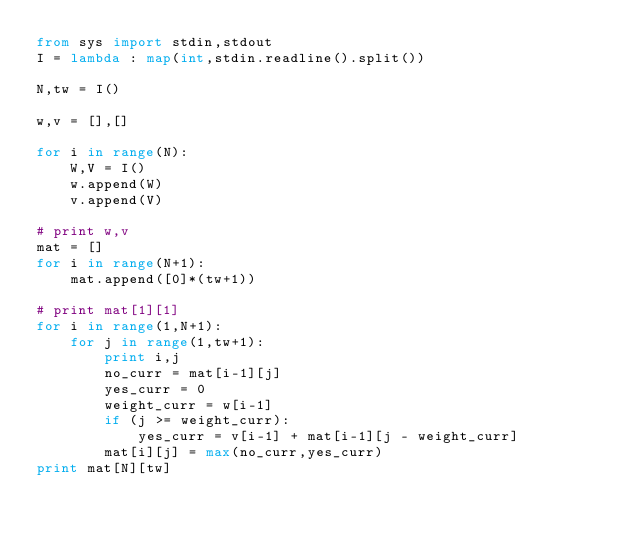Convert code to text. <code><loc_0><loc_0><loc_500><loc_500><_Python_>from sys import stdin,stdout
I = lambda : map(int,stdin.readline().split())

N,tw = I()

w,v = [],[]

for i in range(N):
	W,V = I()
	w.append(W)
	v.append(V)

# print w,v
mat = []
for i in range(N+1):
	mat.append([0]*(tw+1))

# print mat[1][1]
for i in range(1,N+1):
	for j in range(1,tw+1):
		print i,j
		no_curr = mat[i-1][j]
		yes_curr = 0
		weight_curr = w[i-1]
		if (j >= weight_curr):
			yes_curr = v[i-1] + mat[i-1][j - weight_curr]
		mat[i][j] = max(no_curr,yes_curr)
print mat[N][tw]</code> 